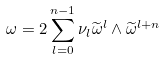Convert formula to latex. <formula><loc_0><loc_0><loc_500><loc_500>\omega = 2 \sum _ { l = 0 } ^ { n - 1 } \nu _ { l } \widetilde { \omega } ^ { l } \wedge \widetilde { \omega } ^ { l + n }</formula> 